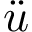Convert formula to latex. <formula><loc_0><loc_0><loc_500><loc_500>\ddot { u }</formula> 